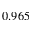Convert formula to latex. <formula><loc_0><loc_0><loc_500><loc_500>0 . 9 6 5</formula> 